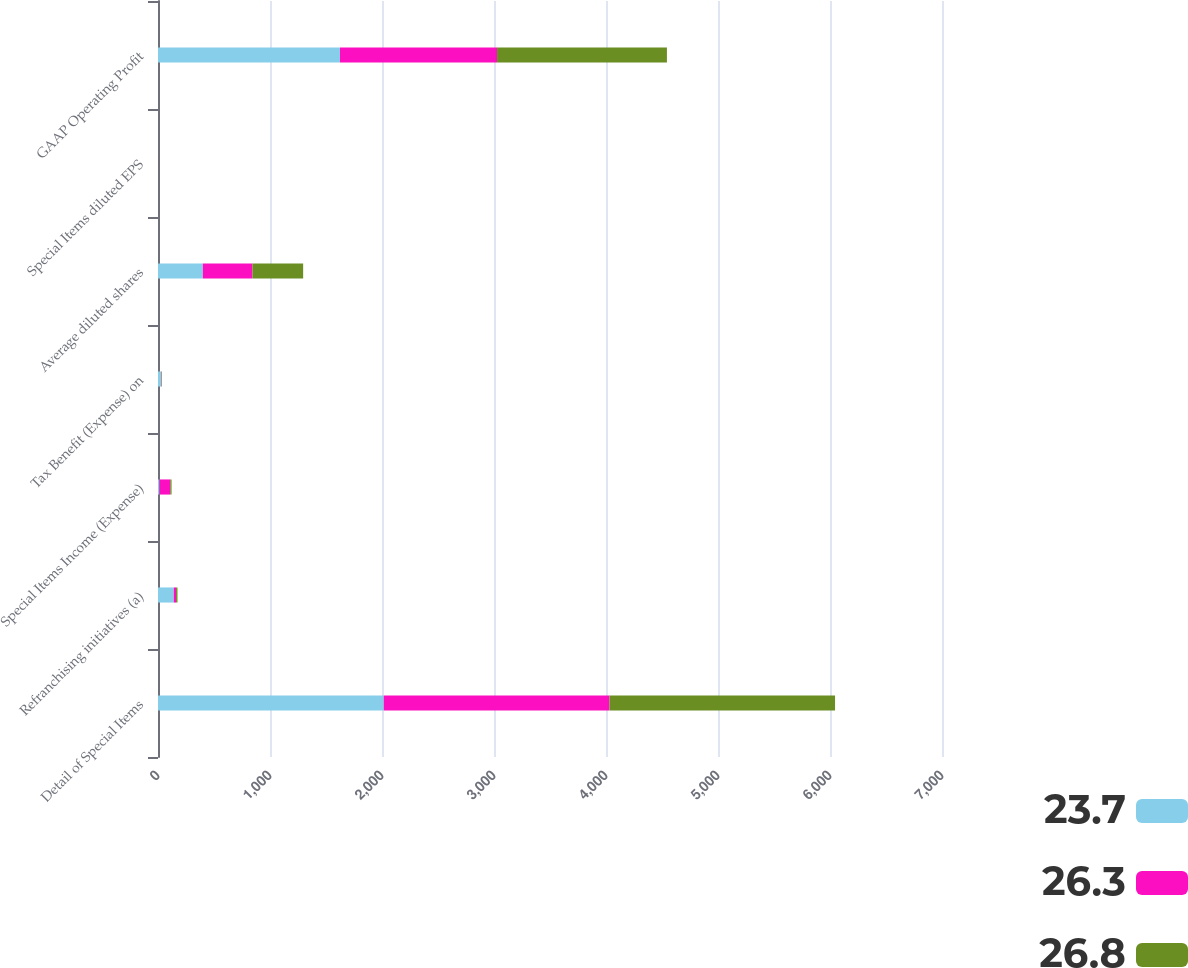<chart> <loc_0><loc_0><loc_500><loc_500><stacked_bar_chart><ecel><fcel>Detail of Special Items<fcel>Refranchising initiatives (a)<fcel>Special Items Income (Expense)<fcel>Tax Benefit (Expense) on<fcel>Average diluted shares<fcel>Special Items diluted EPS<fcel>GAAP Operating Profit<nl><fcel>23.7<fcel>2016<fcel>141<fcel>13<fcel>27<fcel>400<fcel>0.03<fcel>1625<nl><fcel>26.3<fcel>2015<fcel>20<fcel>96<fcel>4<fcel>443<fcel>0.22<fcel>1402<nl><fcel>26.8<fcel>2014<fcel>13<fcel>12<fcel>4<fcel>453<fcel>0.02<fcel>1517<nl></chart> 